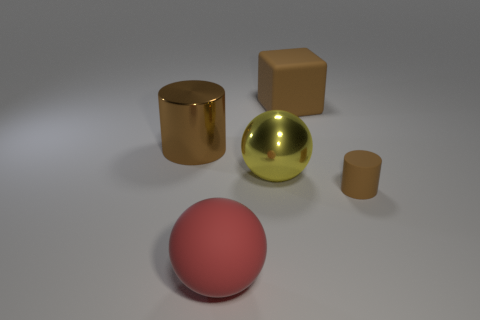Add 1 rubber balls. How many objects exist? 6 Subtract 0 gray spheres. How many objects are left? 5 Subtract all cylinders. How many objects are left? 3 Subtract all metal cylinders. Subtract all big matte blocks. How many objects are left? 3 Add 4 yellow metal things. How many yellow metal things are left? 5 Add 5 blocks. How many blocks exist? 6 